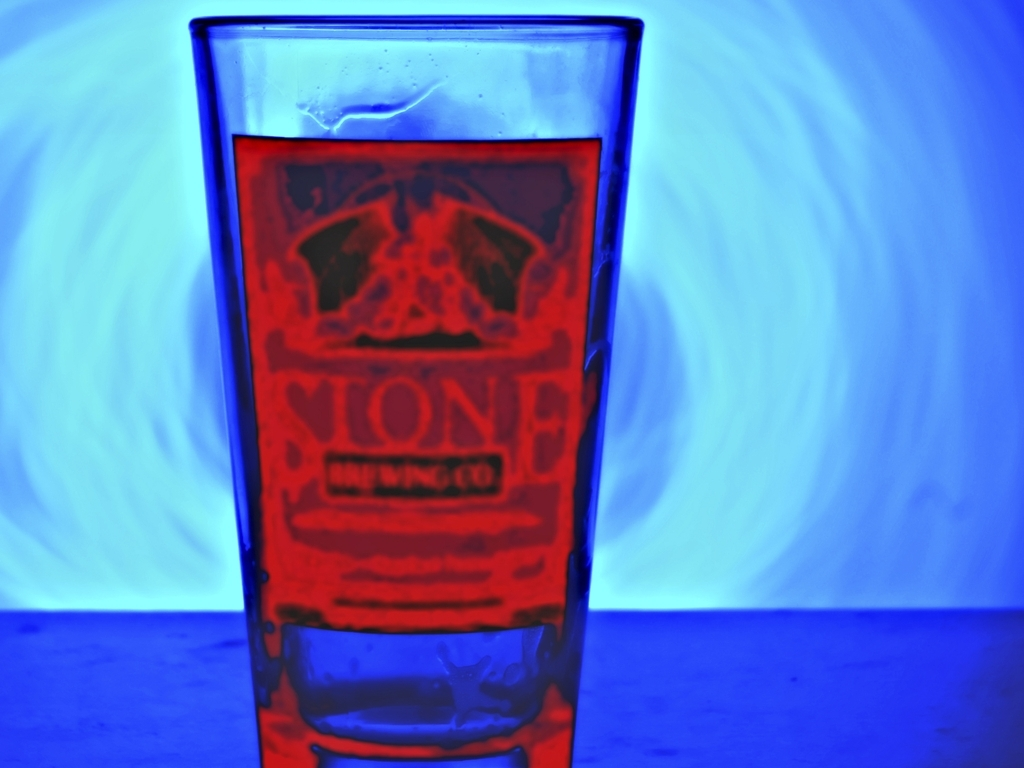What is the lighting condition in the image? A. Bright B. Overexposed C. Insufficient D. Sufficient Answer with the option's letter from the given choices directly. The lighting condition in the image can be described as sufficient, which aligns with option D. Despite the vivid play of blue hues in the background and the strong contrast presented on the glass, the details remain visible and clear, indicating the lighting isn't so poor as to obscure important features nor overexposed to a point that it washes out the image. The level of illumination provides a balanced visibility. 